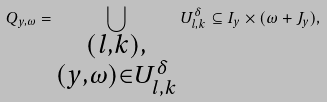<formula> <loc_0><loc_0><loc_500><loc_500>Q _ { y , \omega } = \bigcup _ { \substack { ( l , k ) , \\ ( y , \omega ) \in U _ { l , k } ^ { \delta } } } U _ { l , k } ^ { \delta } \subseteq I _ { y } \times ( \omega + J _ { y } ) ,</formula> 